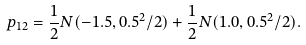Convert formula to latex. <formula><loc_0><loc_0><loc_500><loc_500>p _ { 1 2 } = \frac { 1 } { 2 } N ( - 1 . 5 , 0 . 5 ^ { 2 } / 2 ) + \frac { 1 } { 2 } N ( 1 . 0 , 0 . 5 ^ { 2 } / 2 ) .</formula> 